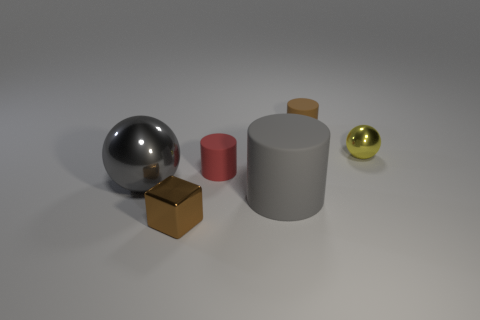Is the number of cyan rubber blocks greater than the number of big metallic things?
Provide a succinct answer. No. Is the gray rubber object the same shape as the big gray metallic object?
Keep it short and to the point. No. Is there any other thing that has the same shape as the yellow thing?
Your response must be concise. Yes. Is the color of the metallic thing that is on the right side of the brown block the same as the big object that is to the left of the shiny cube?
Provide a succinct answer. No. Are there fewer cylinders behind the small red object than small yellow objects that are behind the brown matte cylinder?
Offer a terse response. No. There is a brown thing that is right of the large gray rubber cylinder; what is its shape?
Give a very brief answer. Cylinder. What material is the object that is the same color as the large sphere?
Provide a succinct answer. Rubber. How many other objects are there of the same material as the red cylinder?
Your response must be concise. 2. There is a tiny red matte object; does it have the same shape as the tiny metal object in front of the small ball?
Give a very brief answer. No. What shape is the gray thing that is made of the same material as the red cylinder?
Your answer should be very brief. Cylinder. 